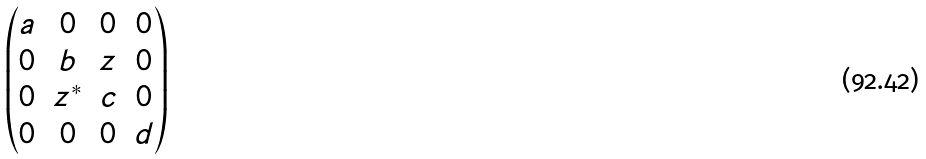<formula> <loc_0><loc_0><loc_500><loc_500>\begin{pmatrix} a & 0 & 0 & 0 \\ 0 & b & z & 0 \\ 0 & z ^ { * } & c & 0 \\ 0 & 0 & 0 & d \end{pmatrix}</formula> 